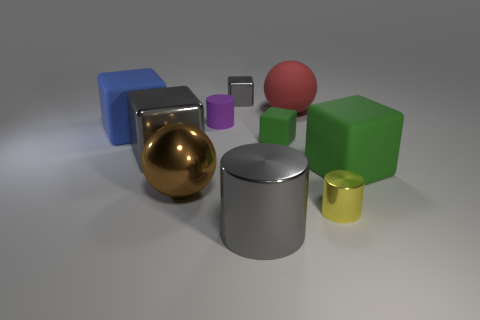Subtract all tiny cylinders. How many cylinders are left? 1 Subtract all green blocks. How many blocks are left? 3 Subtract all spheres. How many objects are left? 8 Subtract 1 spheres. How many spheres are left? 1 Subtract all yellow balls. How many blue cylinders are left? 0 Subtract all gray cylinders. Subtract all large red spheres. How many objects are left? 8 Add 2 blue cubes. How many blue cubes are left? 3 Add 9 small gray blocks. How many small gray blocks exist? 10 Subtract 1 red balls. How many objects are left? 9 Subtract all yellow balls. Subtract all red cylinders. How many balls are left? 2 